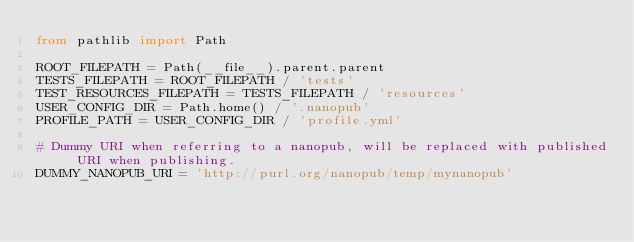Convert code to text. <code><loc_0><loc_0><loc_500><loc_500><_Python_>from pathlib import Path

ROOT_FILEPATH = Path(__file__).parent.parent
TESTS_FILEPATH = ROOT_FILEPATH / 'tests'
TEST_RESOURCES_FILEPATH = TESTS_FILEPATH / 'resources'
USER_CONFIG_DIR = Path.home() / '.nanopub'
PROFILE_PATH = USER_CONFIG_DIR / 'profile.yml'

# Dummy URI when referring to a nanopub, will be replaced with published URI when publishing.
DUMMY_NANOPUB_URI = 'http://purl.org/nanopub/temp/mynanopub'
</code> 